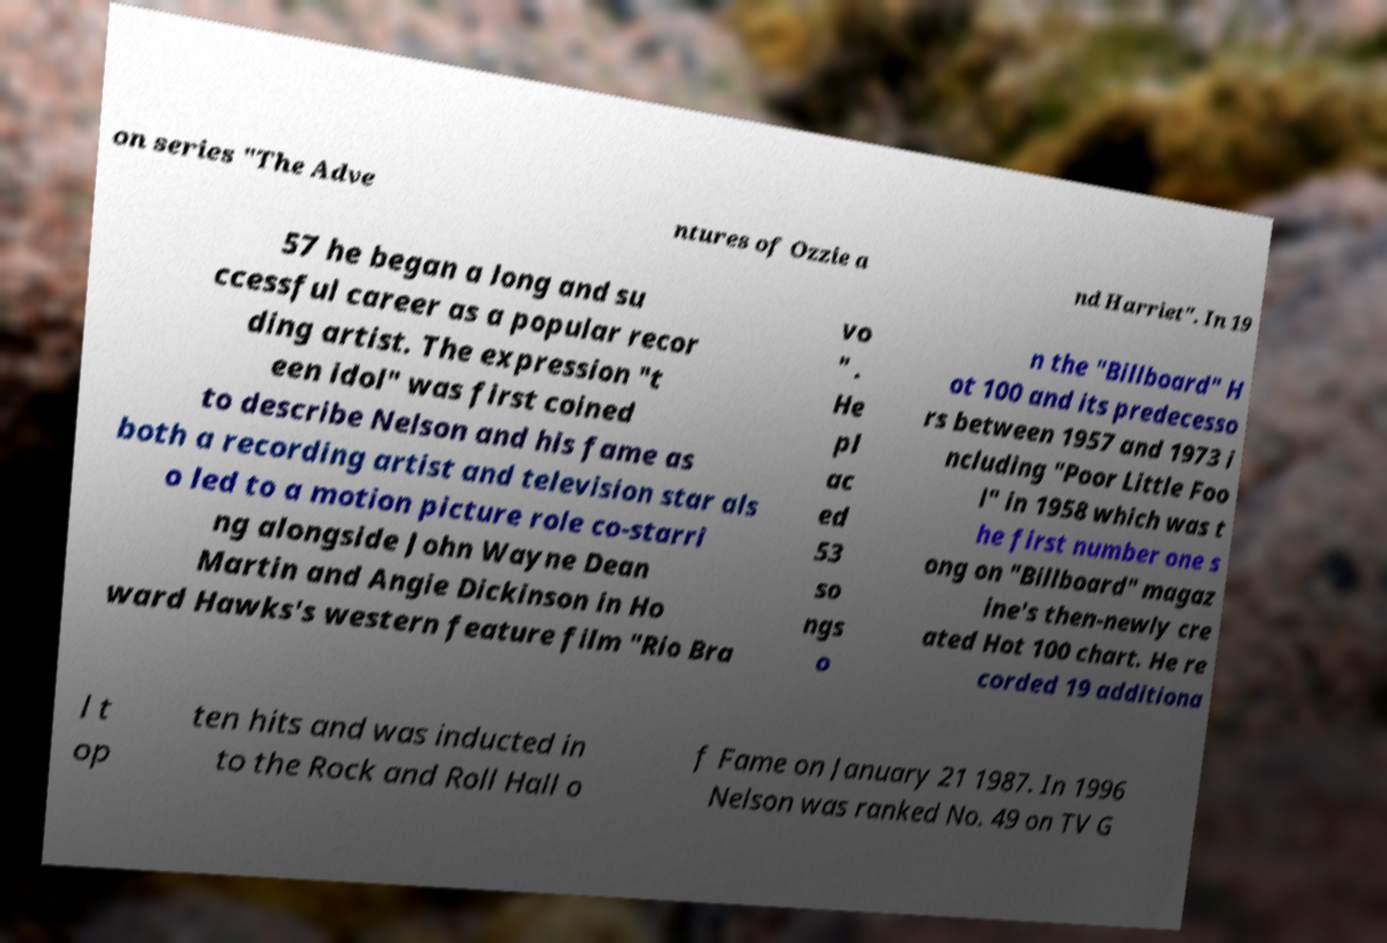Can you accurately transcribe the text from the provided image for me? on series "The Adve ntures of Ozzie a nd Harriet". In 19 57 he began a long and su ccessful career as a popular recor ding artist. The expression "t een idol" was first coined to describe Nelson and his fame as both a recording artist and television star als o led to a motion picture role co-starri ng alongside John Wayne Dean Martin and Angie Dickinson in Ho ward Hawks's western feature film "Rio Bra vo " . He pl ac ed 53 so ngs o n the "Billboard" H ot 100 and its predecesso rs between 1957 and 1973 i ncluding "Poor Little Foo l" in 1958 which was t he first number one s ong on "Billboard" magaz ine's then-newly cre ated Hot 100 chart. He re corded 19 additiona l t op ten hits and was inducted in to the Rock and Roll Hall o f Fame on January 21 1987. In 1996 Nelson was ranked No. 49 on TV G 